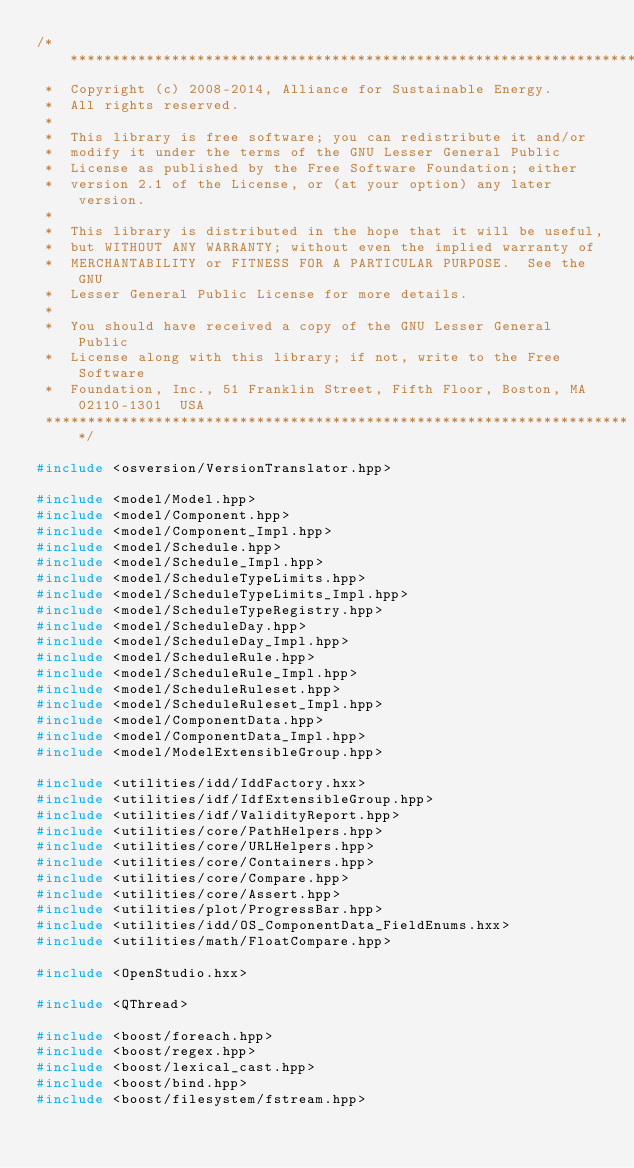Convert code to text. <code><loc_0><loc_0><loc_500><loc_500><_C++_>/**********************************************************************
 *  Copyright (c) 2008-2014, Alliance for Sustainable Energy.
 *  All rights reserved.
 *
 *  This library is free software; you can redistribute it and/or
 *  modify it under the terms of the GNU Lesser General Public
 *  License as published by the Free Software Foundation; either
 *  version 2.1 of the License, or (at your option) any later version.
 *
 *  This library is distributed in the hope that it will be useful,
 *  but WITHOUT ANY WARRANTY; without even the implied warranty of
 *  MERCHANTABILITY or FITNESS FOR A PARTICULAR PURPOSE.  See the GNU
 *  Lesser General Public License for more details.
 *
 *  You should have received a copy of the GNU Lesser General Public
 *  License along with this library; if not, write to the Free Software
 *  Foundation, Inc., 51 Franklin Street, Fifth Floor, Boston, MA  02110-1301  USA
 **********************************************************************/

#include <osversion/VersionTranslator.hpp>

#include <model/Model.hpp>
#include <model/Component.hpp>
#include <model/Component_Impl.hpp>
#include <model/Schedule.hpp>
#include <model/Schedule_Impl.hpp>
#include <model/ScheduleTypeLimits.hpp>
#include <model/ScheduleTypeLimits_Impl.hpp>
#include <model/ScheduleTypeRegistry.hpp>
#include <model/ScheduleDay.hpp>
#include <model/ScheduleDay_Impl.hpp>
#include <model/ScheduleRule.hpp>
#include <model/ScheduleRule_Impl.hpp>
#include <model/ScheduleRuleset.hpp>
#include <model/ScheduleRuleset_Impl.hpp>
#include <model/ComponentData.hpp>
#include <model/ComponentData_Impl.hpp>
#include <model/ModelExtensibleGroup.hpp>

#include <utilities/idd/IddFactory.hxx>
#include <utilities/idf/IdfExtensibleGroup.hpp>
#include <utilities/idf/ValidityReport.hpp>
#include <utilities/core/PathHelpers.hpp>
#include <utilities/core/URLHelpers.hpp>
#include <utilities/core/Containers.hpp>
#include <utilities/core/Compare.hpp>
#include <utilities/core/Assert.hpp>
#include <utilities/plot/ProgressBar.hpp>
#include <utilities/idd/OS_ComponentData_FieldEnums.hxx>
#include <utilities/math/FloatCompare.hpp>

#include <OpenStudio.hxx>

#include <QThread>

#include <boost/foreach.hpp>
#include <boost/regex.hpp>
#include <boost/lexical_cast.hpp>
#include <boost/bind.hpp>
#include <boost/filesystem/fstream.hpp>
</code> 